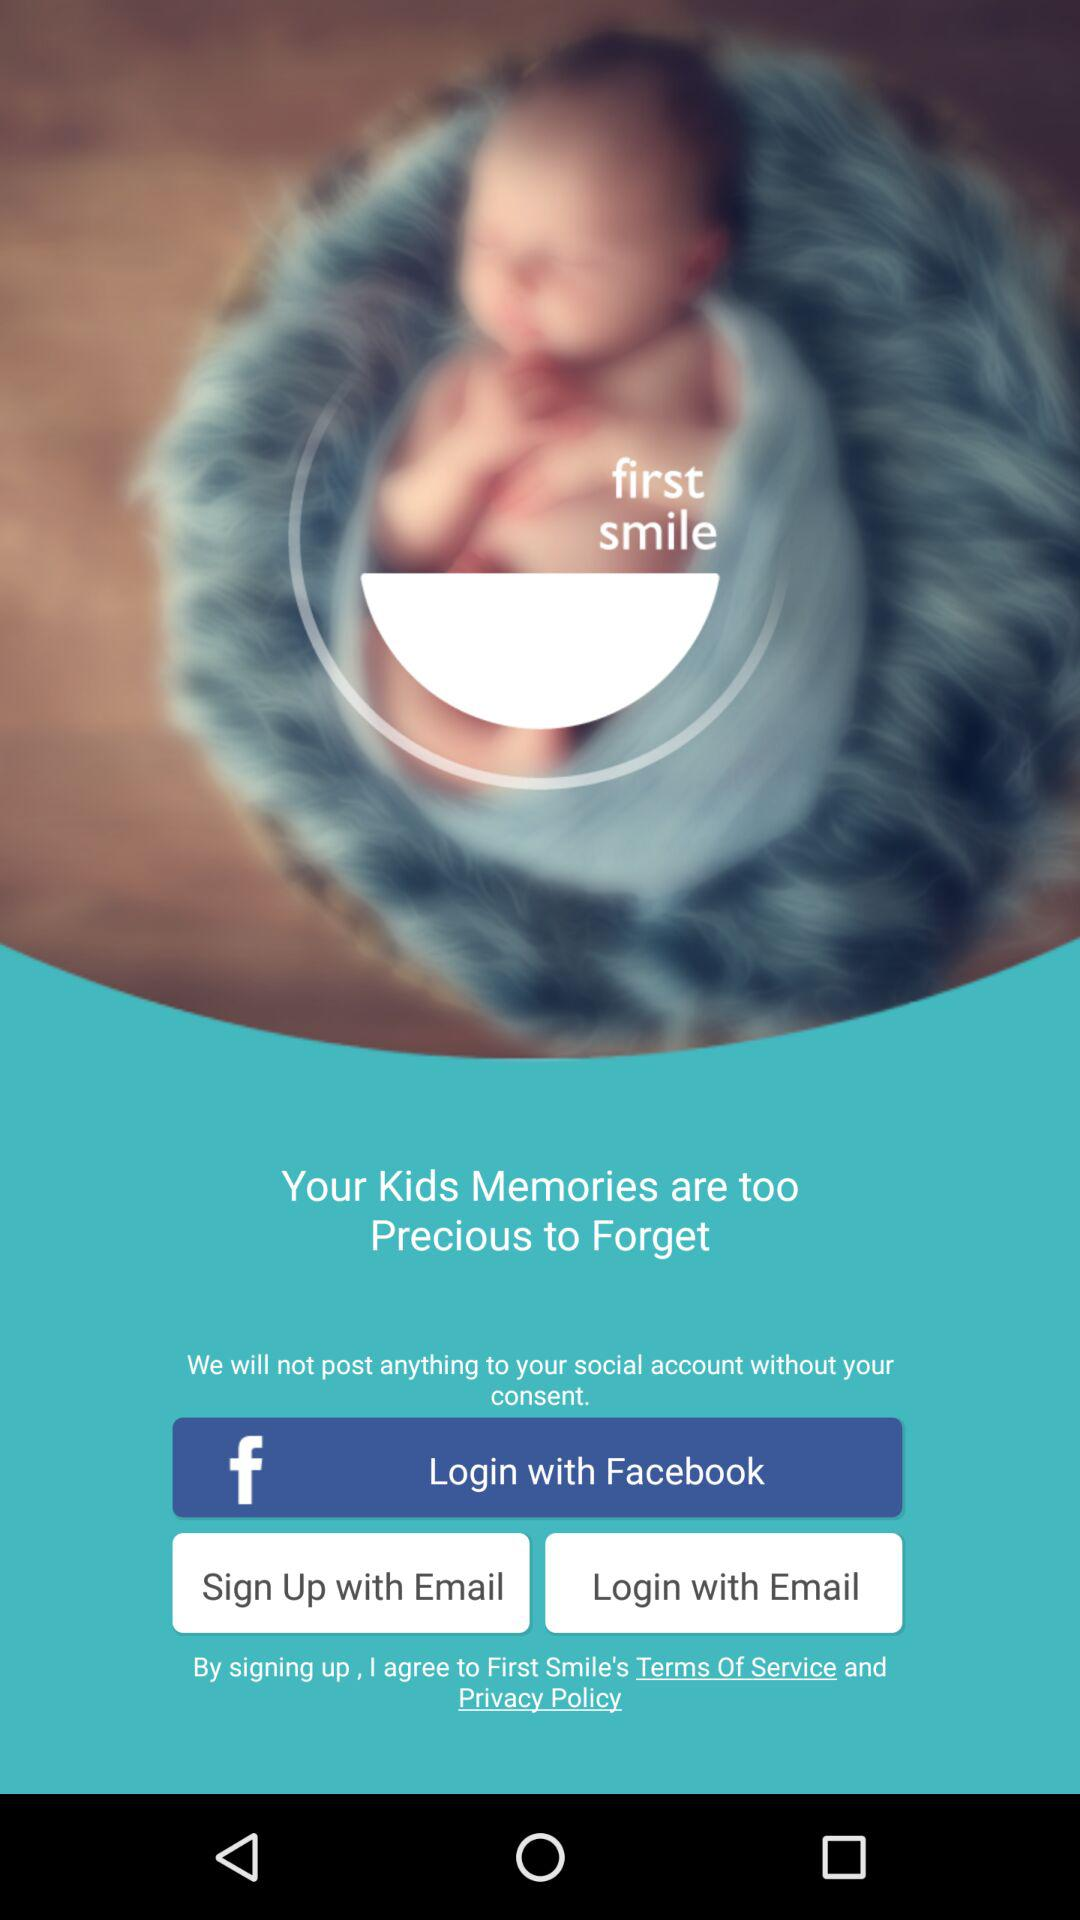What is the name of the application? The name of the application is "first smile". 